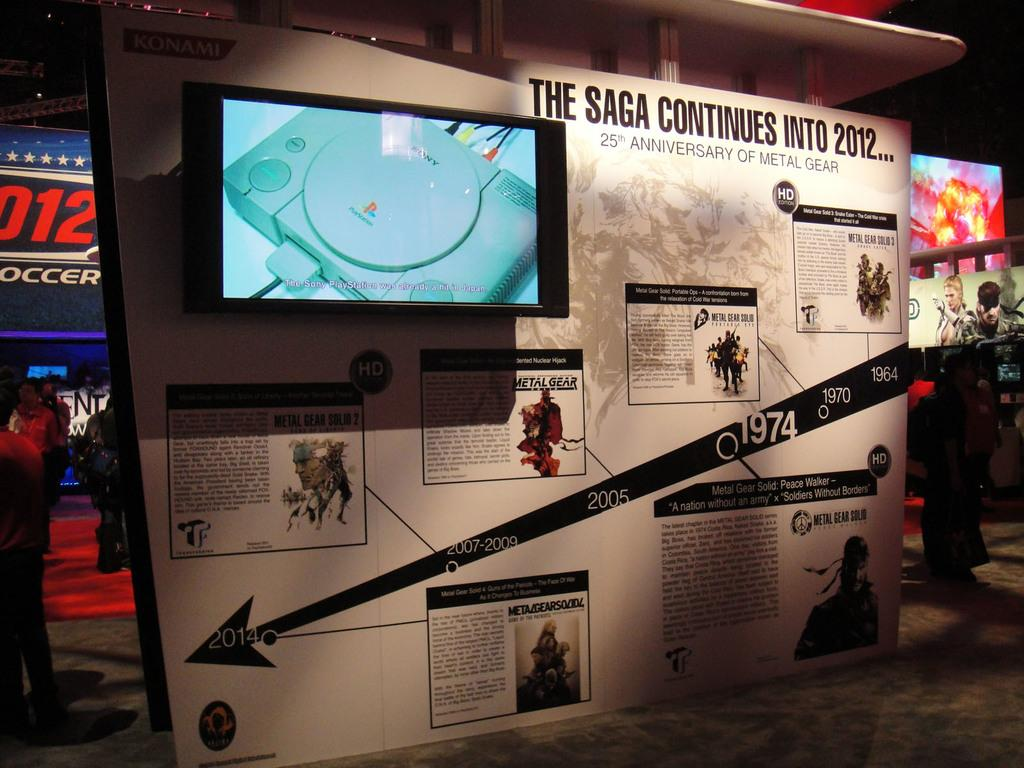<image>
Summarize the visual content of the image. Board titled "The Sage Continues in 2012" showing a screen of a game console. 